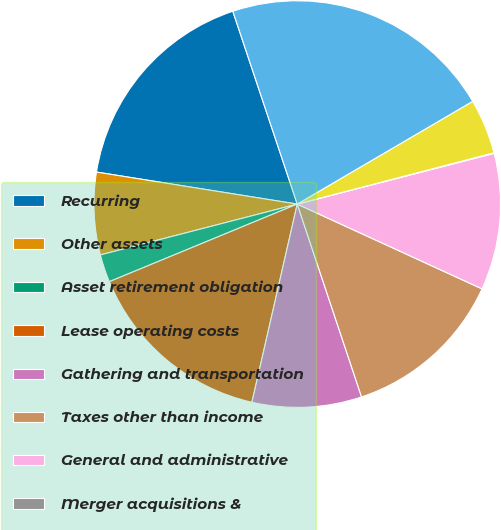Convert chart to OTSL. <chart><loc_0><loc_0><loc_500><loc_500><pie_chart><fcel>Recurring<fcel>Other assets<fcel>Asset retirement obligation<fcel>Lease operating costs<fcel>Gathering and transportation<fcel>Taxes other than income<fcel>General and administrative<fcel>Merger acquisitions &<fcel>Financing costs net<fcel>Total<nl><fcel>17.35%<fcel>6.54%<fcel>2.21%<fcel>15.19%<fcel>8.7%<fcel>13.03%<fcel>10.86%<fcel>0.05%<fcel>4.37%<fcel>21.7%<nl></chart> 